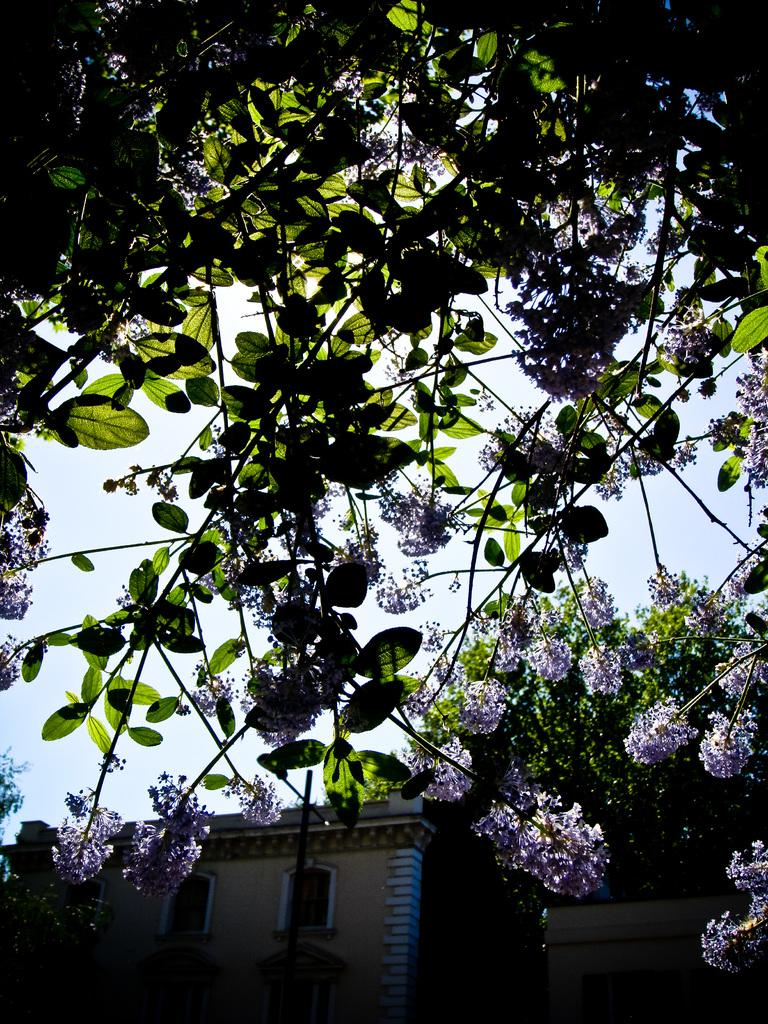What type of structure is present in the picture? There is a building in the picture. What type of plants can be seen in the picture? There are flowers and trees in the picture. What can be seen in the background of the picture? The sky is visible in the background of the picture. How many goldfish are swimming in the fountain in the picture? There is no fountain or goldfish present in the image. What statement is being made by the flowers in the picture? The flowers in the picture are not making any statements; they are simply plants. 